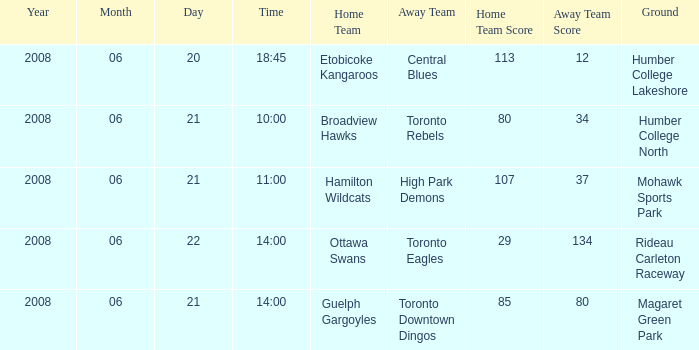What is the Away with a Ground that is humber college lakeshore? Central Blues. 